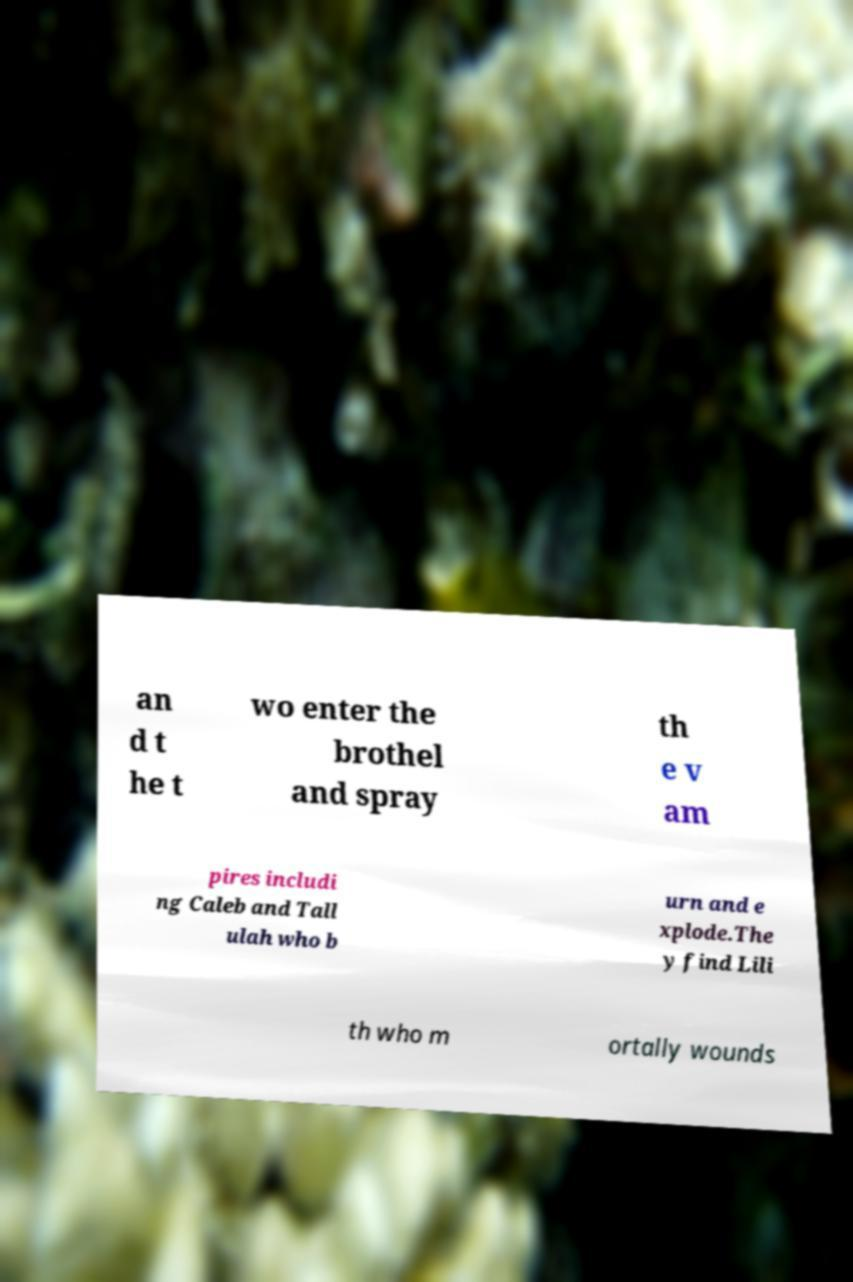Please read and relay the text visible in this image. What does it say? an d t he t wo enter the brothel and spray th e v am pires includi ng Caleb and Tall ulah who b urn and e xplode.The y find Lili th who m ortally wounds 